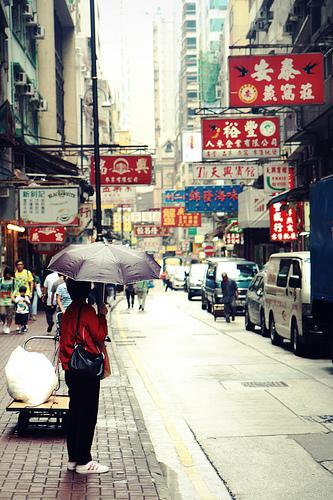Question: what is int he background?
Choices:
A. Buildings.
B. Trees.
C. Mountains.
D. Plants.
Answer with the letter. Answer: A Question: who is standing on the street corner?
Choices:
A. The person wearing a back pack.
B. The woman in the red dress.
C. The person with the umbrella.
D. The man with the hat.
Answer with the letter. Answer: C 